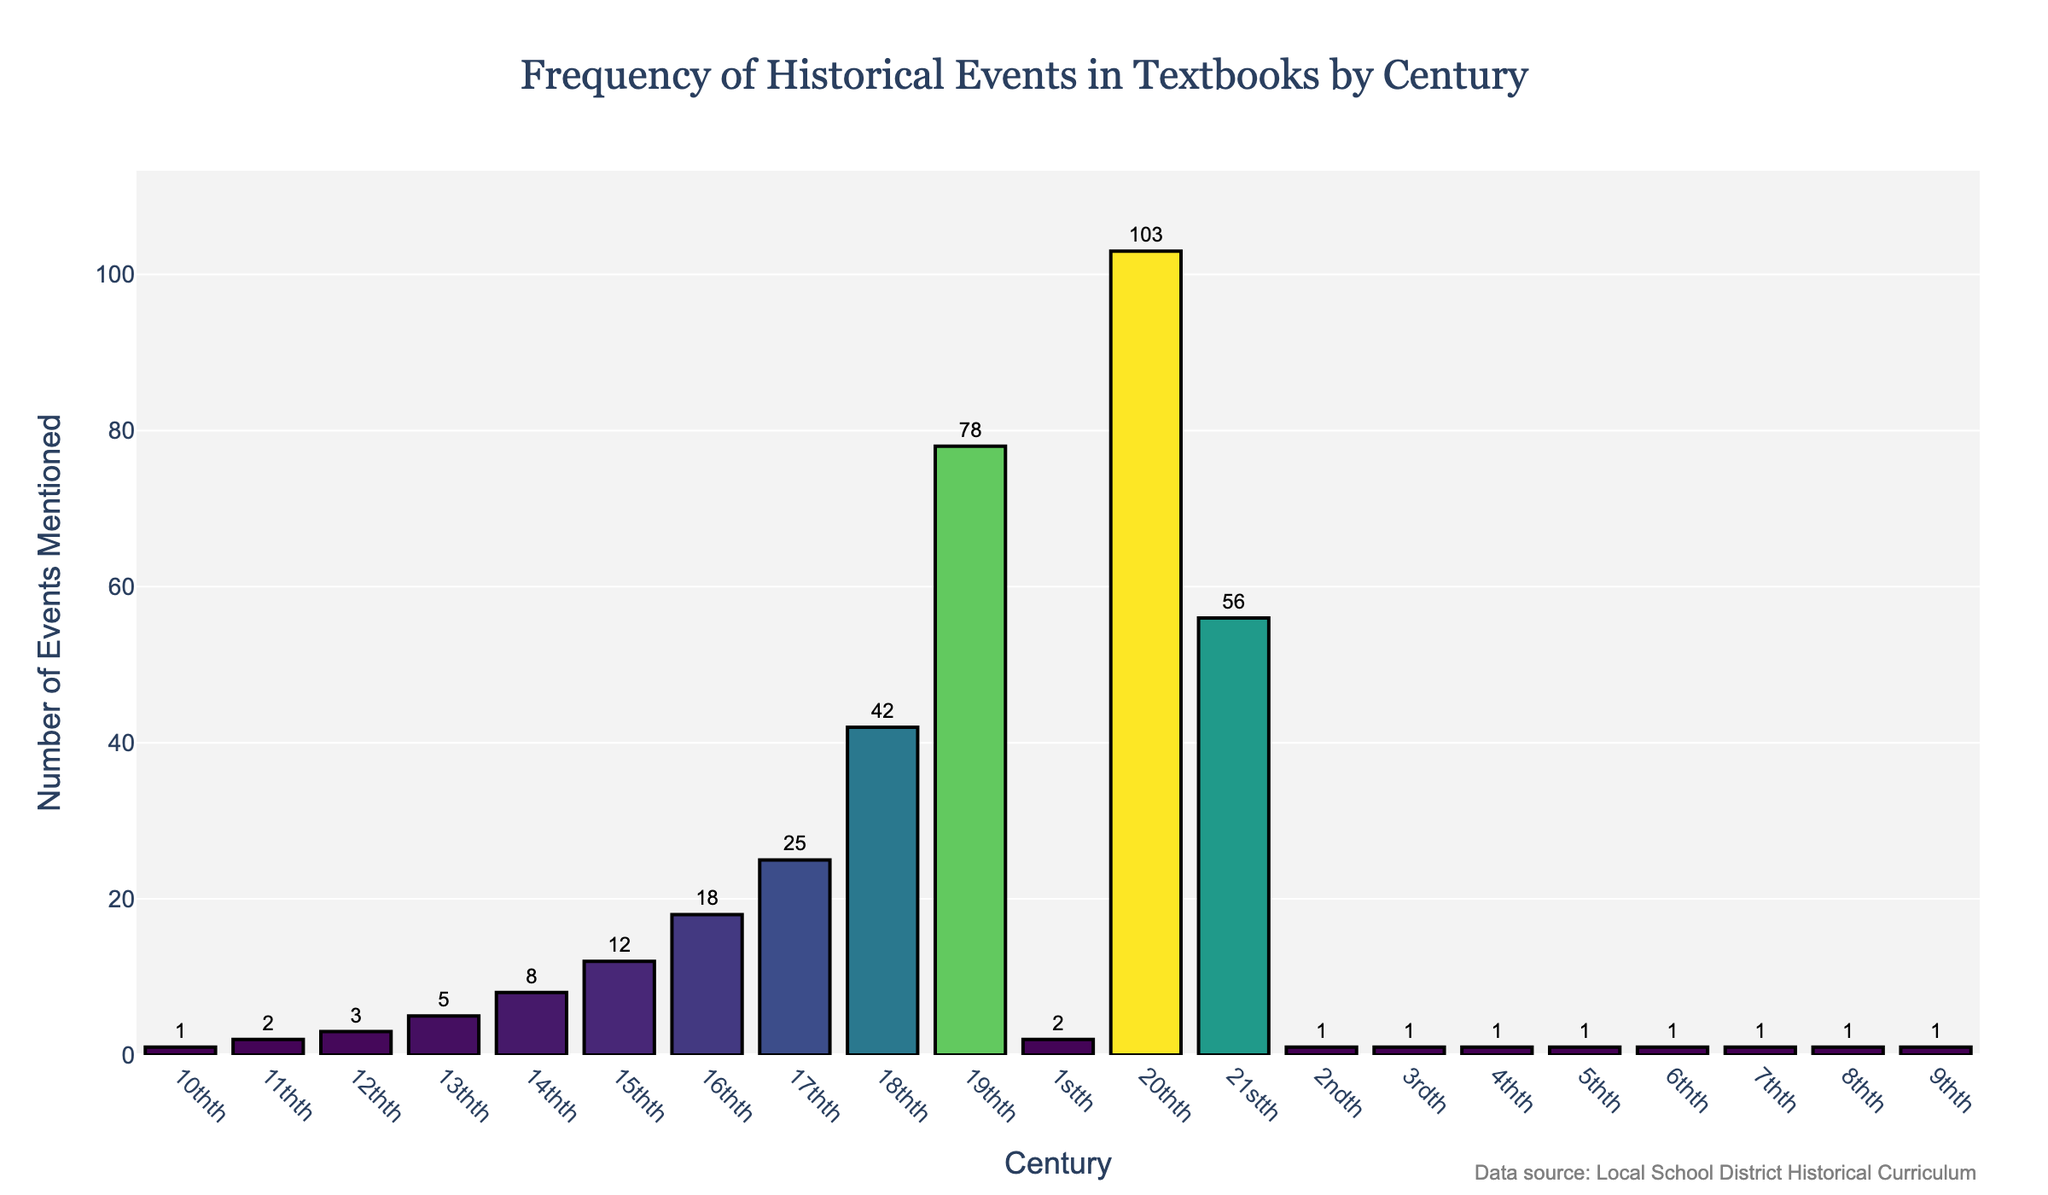What is the title of the figure? The title is usually found at the top of the figure, and in this case, it explicitly states what the plot is about.
Answer: Frequency of Historical Events in Textbooks by Century What century has the highest number of events mentioned? By looking at the height of the bars in the plot, we see that the 20th century has the tallest bar.
Answer: 20th What is the number of events mentioned for the 18th century? By locating the bar corresponding to the 18th century and referring to its height, we see the number displayed.
Answer: 42 How many centuries have 1 event mentioned? By counting the number of bars with a height of 1, the following centuries are identified: 10th, 9th, 8th, 7th, 6th, 5th, 4th, 3rd, 2nd, 1st.
Answer: 9 By how much does the number of events mentioned in the 20th century exceed those in the 19th century? By subtracting the number of events in the 19th century (78) from the 20th century (103), we get the difference.
Answer: 25 Which century has the second-highest number of events mentioned, and what is the count? By identifying the second tallest bar after the 20th century, we see that the 19th century has the second-highest count.
Answer: 19th, 78 What is the sum of the number of historical events mentioned in the 15th and 16th centuries? Adding the number of events for the 15th century (12) and the 16th century (18) gives the total.
Answer: 30 Compare the number of events mentioned in the 21st and 18th centuries. Which century has more, and by how many? By comparing the heights of the bars for the 21st century (56) and the 18th century (42), we find that the 21st century has more events by 14.
Answer: 21st, 14 What is the average number of historical events mentioned for the centuries from the 12th to the 14th? Summing the number of events for the 12th (3), 13th (5), and 14th (8) centuries and dividing by 3 gives the average.
Answer: 5.33 